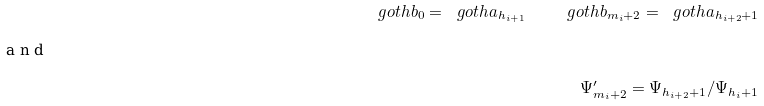Convert formula to latex. <formula><loc_0><loc_0><loc_500><loc_500>\ g o t h { b } _ { 0 } = \ g o t h { a } _ { h _ { i + 1 } } \quad \ g o t h { b } _ { m _ { i } + 2 } = \ g o t h { a } _ { h _ { i + 2 } + 1 } \intertext { a n d } \Psi _ { m _ { i } + 2 } ^ { \prime } = \Psi _ { h _ { i + 2 } + 1 } / \Psi _ { h _ { i } + 1 }</formula> 